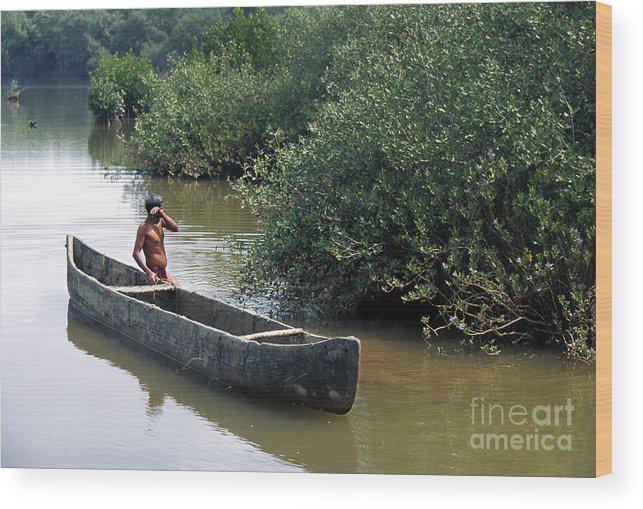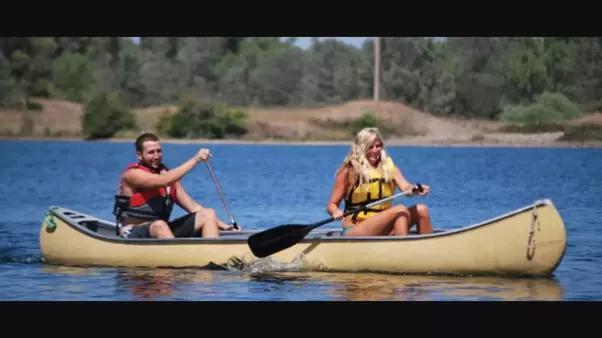The first image is the image on the left, the second image is the image on the right. Examine the images to the left and right. Is the description "In one image, three people, two of them using or sitting near oars, can be seen in a single canoe in a body of water near a shoreline with trees," accurate? Answer yes or no. No. The first image is the image on the left, the second image is the image on the right. Given the left and right images, does the statement "An image includes three people in one canoe on the water." hold true? Answer yes or no. No. 